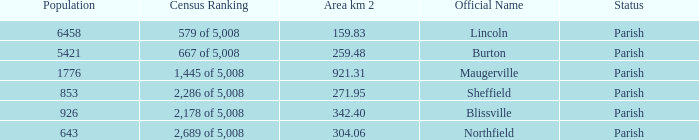What are the official name(s) of places with an area of 304.06 km2? Northfield. 